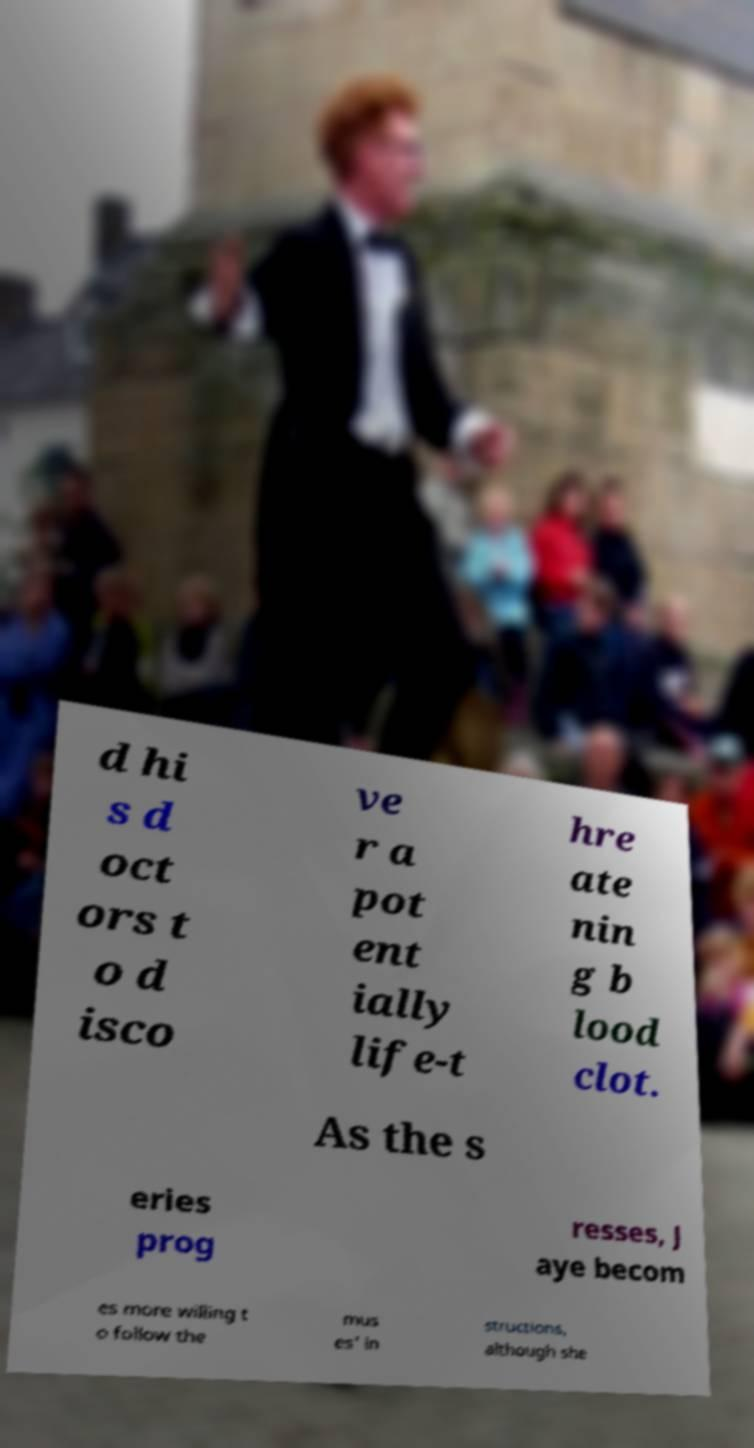Could you assist in decoding the text presented in this image and type it out clearly? d hi s d oct ors t o d isco ve r a pot ent ially life-t hre ate nin g b lood clot. As the s eries prog resses, J aye becom es more willing t o follow the mus es' in structions, although she 